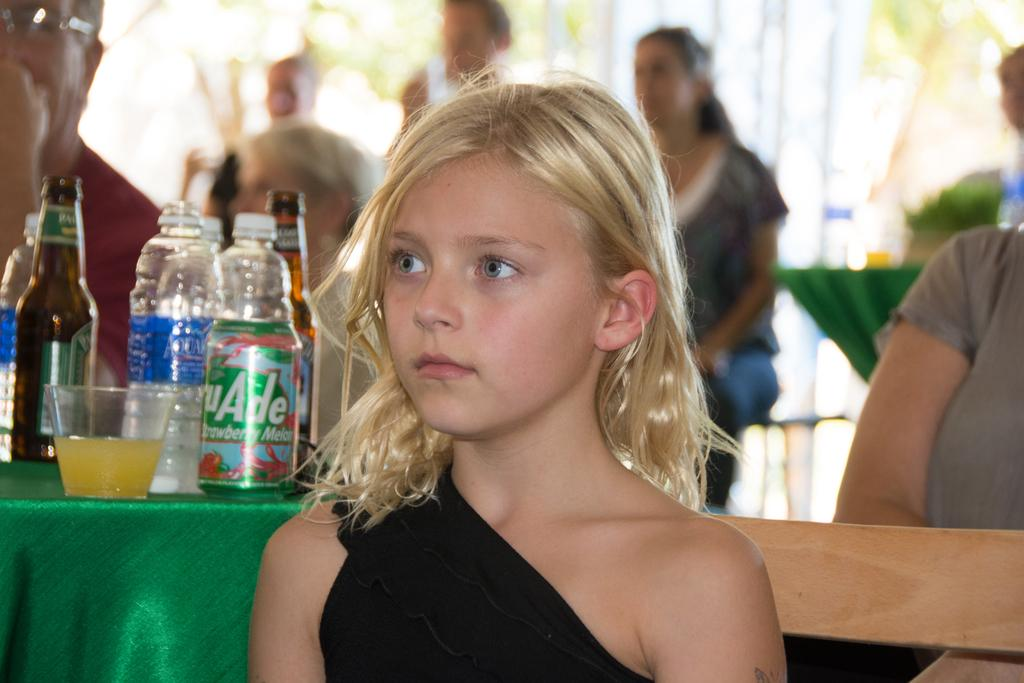What type of objects can be seen in the image? There are bottles in the image. What is the color of the cloth on which objects are placed? The color of the cloth is green. Can you describe the people in the image? There are people in the image, but their specific characteristics are not mentioned in the facts. What can be said about the background of the image? The background of the image is blurred. What direction are the people in the image facing? The facts provided do not mention the direction the people are facing, so we cannot answer this question definitively. --- Facts: 1. There is a car in the image. 2. The car is red. 3. The car has four wheels. 4. There is a road in the image. 5. The road is paved. Absurd Topics: parrot, ocean, bicycle Conversation: What type of vehicle is in the image? There is a car in the image. What color is the car? The car is red. How many wheels does the car have? The car has four wheels. What type of surface is visible in the image? There is a road in the image, and it is paved. Reasoning: Let's think step by step in order to produce the conversation. We start by identifying the main subject in the image, which is the car. Then, we describe the color and number of wheels of the car. Next, we mention the presence of a road in the image and specify that it is paved. Each question is designed to elicit a specific detail about the image that is known from the provided facts. Absurd Question/Answer: Can you see a parrot flying over the ocean in the image? There is no mention of a parrot or an ocean in the image, so we cannot answer this question definitively. 